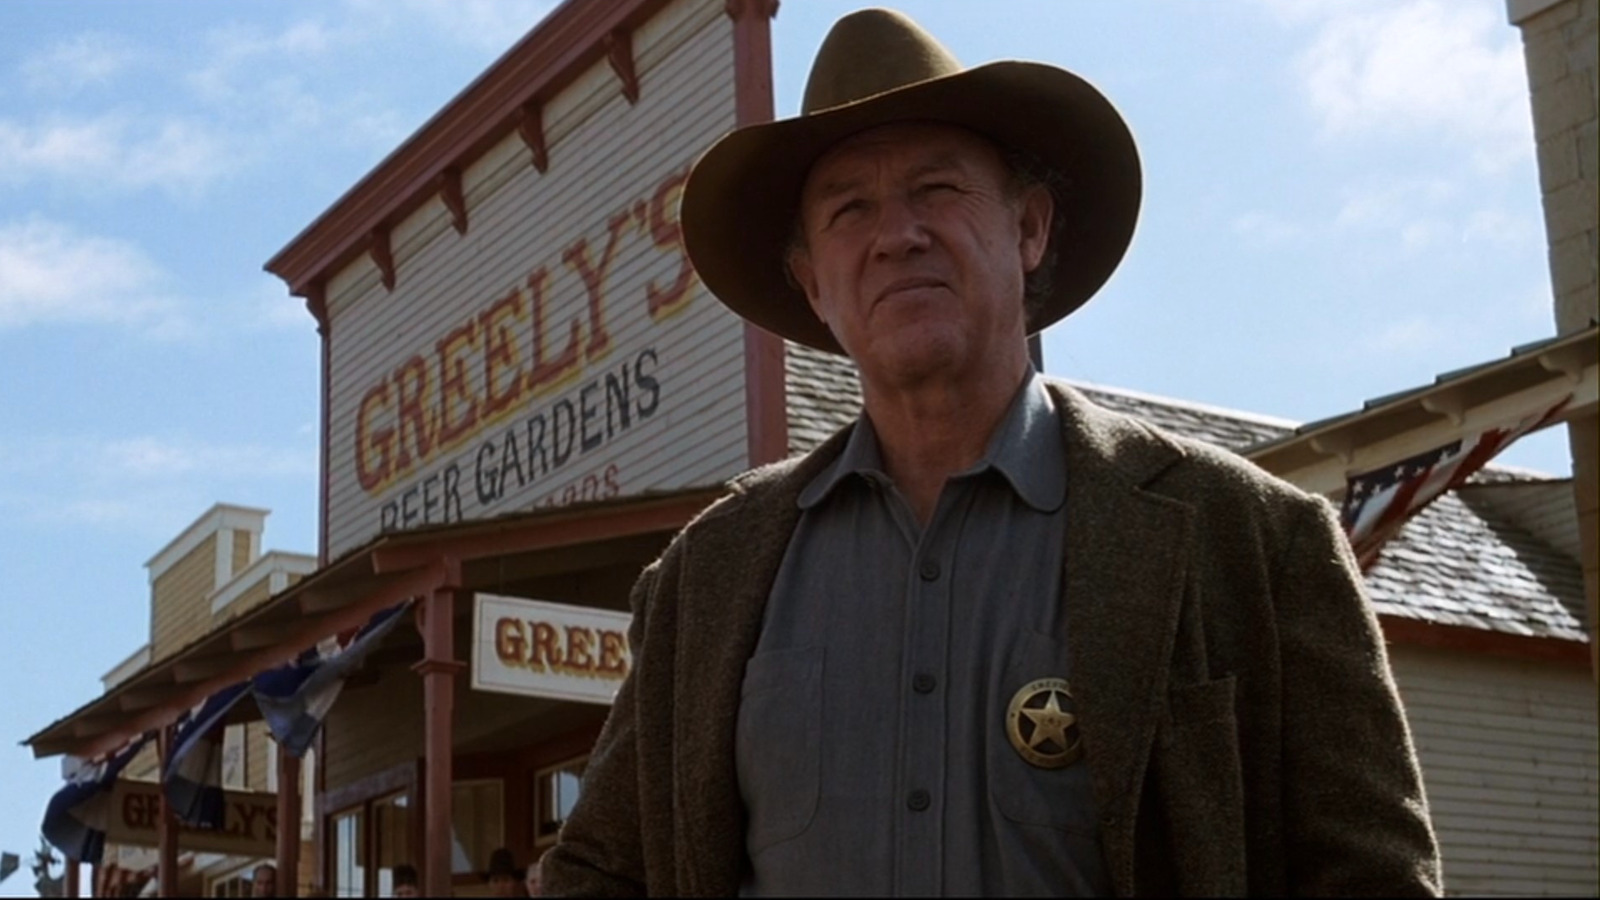What symbolic significance might the gold badge hold in this image? The gold badge in the image symbolizes authority, law, and order in the setting of the old west. It signifies the sheriff's role as a protector of the town, upholding justice in a time and place where the rule of law was often challenged. The badge is a mark of respect and responsibility, representing the sheriff's commitment to maintaining peace and defending the community against lawlessness. 